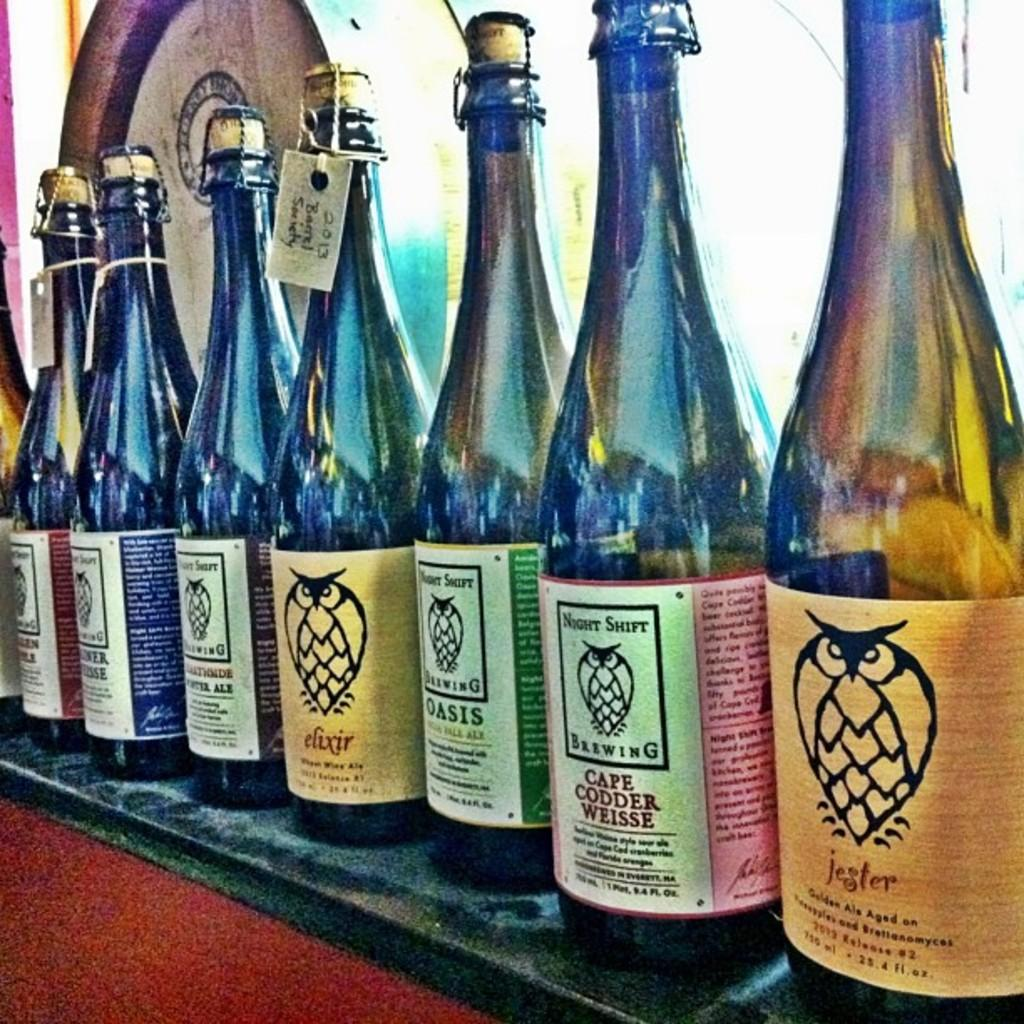<image>
Offer a succinct explanation of the picture presented. A row of wine bottles on a shelf made by Night Shift Brewing. 